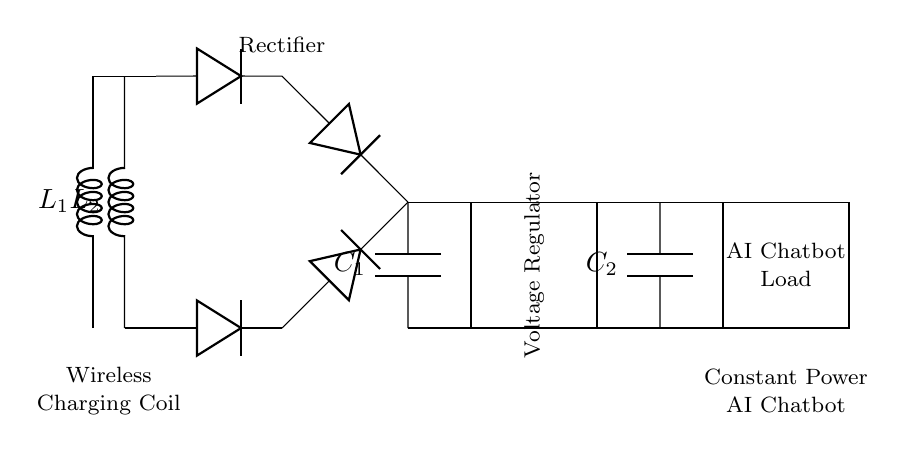What are the main components in this circuit? The main components in the circuit are two inductors, four diodes, two capacitors, and a voltage regulator. Each component plays a specific role in the wireless charging and power regulation process.
Answer: Inductors, diodes, capacitors, voltage regulator What is the purpose of the smoothing capacitor? The purpose of the smoothing capacitor is to reduce voltage ripple after the rectification process, ensuring that the output voltage is more stable for the AI chatbot load. This stabilization is crucial for the proper operation of sensitive electronics like chatbots.
Answer: Reduce voltage ripple How many diodes are used in the rectifier? There are four diodes used in the rectifier section of the circuit. This is necessary to convert the AC waveform induced in the coils into a usable DC output for the subsequent components.
Answer: Four What does the voltage regulator do in this circuit? The voltage regulator maintains a constant output voltage for the AI chatbot, regardless of variations in input voltage or load current. This regulation ensures reliable operation of the chatbot under fluctuating conditions.
Answer: Maintains constant output voltage What is the total capacitance at the output? The total capacitance at the output consists of the output capacitor and can be described as the value of capacitor C2. Since there are no numeric values provided in the question, one can interpret that the circuit may specify a capacity for C2.
Answer: C2 (value not specified) Which part of the circuit maintains power for the AI chatbot? The load labeled as AI Chatbot is supplied with power through the voltage regulator, which receives a stable voltage from the smoothing capacitor after the rectification. This allows continuous power delivery to the chatbot.
Answer: Voltage regulator 